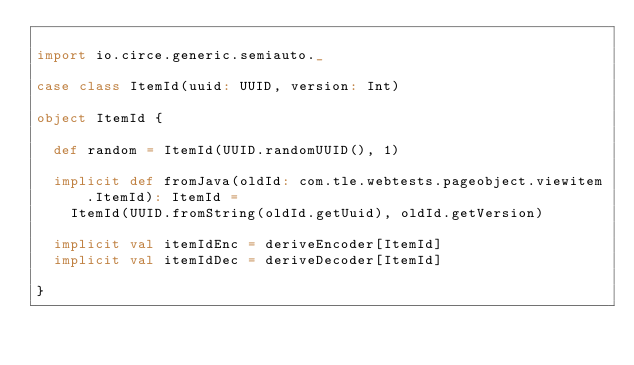<code> <loc_0><loc_0><loc_500><loc_500><_Scala_>
import io.circe.generic.semiauto._

case class ItemId(uuid: UUID, version: Int)

object ItemId {

  def random = ItemId(UUID.randomUUID(), 1)

  implicit def fromJava(oldId: com.tle.webtests.pageobject.viewitem.ItemId): ItemId =
    ItemId(UUID.fromString(oldId.getUuid), oldId.getVersion)

  implicit val itemIdEnc = deriveEncoder[ItemId]
  implicit val itemIdDec = deriveDecoder[ItemId]

}
</code> 